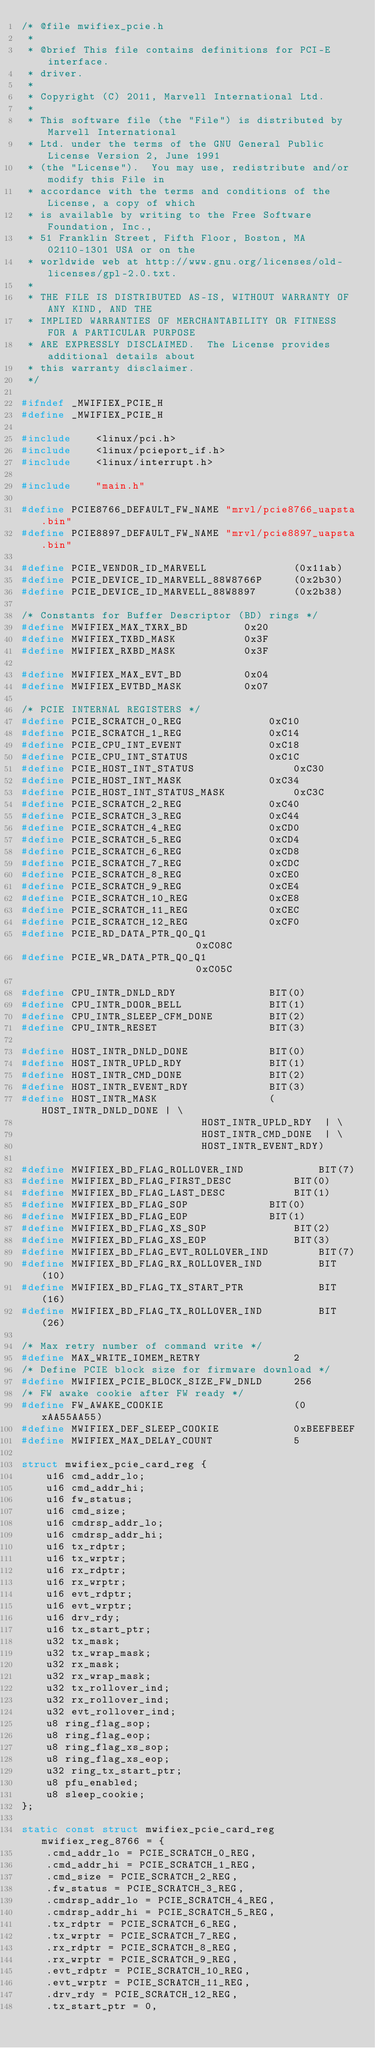Convert code to text. <code><loc_0><loc_0><loc_500><loc_500><_C_>/* @file mwifiex_pcie.h
 *
 * @brief This file contains definitions for PCI-E interface.
 * driver.
 *
 * Copyright (C) 2011, Marvell International Ltd.
 *
 * This software file (the "File") is distributed by Marvell International
 * Ltd. under the terms of the GNU General Public License Version 2, June 1991
 * (the "License").  You may use, redistribute and/or modify this File in
 * accordance with the terms and conditions of the License, a copy of which
 * is available by writing to the Free Software Foundation, Inc.,
 * 51 Franklin Street, Fifth Floor, Boston, MA 02110-1301 USA or on the
 * worldwide web at http://www.gnu.org/licenses/old-licenses/gpl-2.0.txt.
 *
 * THE FILE IS DISTRIBUTED AS-IS, WITHOUT WARRANTY OF ANY KIND, AND THE
 * IMPLIED WARRANTIES OF MERCHANTABILITY OR FITNESS FOR A PARTICULAR PURPOSE
 * ARE EXPRESSLY DISCLAIMED.  The License provides additional details about
 * this warranty disclaimer.
 */

#ifndef	_MWIFIEX_PCIE_H
#define	_MWIFIEX_PCIE_H

#include    <linux/pci.h>
#include    <linux/pcieport_if.h>
#include    <linux/interrupt.h>

#include    "main.h"

#define PCIE8766_DEFAULT_FW_NAME "mrvl/pcie8766_uapsta.bin"
#define PCIE8897_DEFAULT_FW_NAME "mrvl/pcie8897_uapsta.bin"

#define PCIE_VENDOR_ID_MARVELL              (0x11ab)
#define PCIE_DEVICE_ID_MARVELL_88W8766P		(0x2b30)
#define PCIE_DEVICE_ID_MARVELL_88W8897		(0x2b38)

/* Constants for Buffer Descriptor (BD) rings */
#define MWIFIEX_MAX_TXRX_BD			0x20
#define MWIFIEX_TXBD_MASK			0x3F
#define MWIFIEX_RXBD_MASK			0x3F

#define MWIFIEX_MAX_EVT_BD			0x04
#define MWIFIEX_EVTBD_MASK			0x07

/* PCIE INTERNAL REGISTERS */
#define PCIE_SCRATCH_0_REG				0xC10
#define PCIE_SCRATCH_1_REG				0xC14
#define PCIE_CPU_INT_EVENT				0xC18
#define PCIE_CPU_INT_STATUS				0xC1C
#define PCIE_HOST_INT_STATUS				0xC30
#define PCIE_HOST_INT_MASK				0xC34
#define PCIE_HOST_INT_STATUS_MASK			0xC3C
#define PCIE_SCRATCH_2_REG				0xC40
#define PCIE_SCRATCH_3_REG				0xC44
#define PCIE_SCRATCH_4_REG				0xCD0
#define PCIE_SCRATCH_5_REG				0xCD4
#define PCIE_SCRATCH_6_REG				0xCD8
#define PCIE_SCRATCH_7_REG				0xCDC
#define PCIE_SCRATCH_8_REG				0xCE0
#define PCIE_SCRATCH_9_REG				0xCE4
#define PCIE_SCRATCH_10_REG				0xCE8
#define PCIE_SCRATCH_11_REG				0xCEC
#define PCIE_SCRATCH_12_REG				0xCF0
#define PCIE_RD_DATA_PTR_Q0_Q1                          0xC08C
#define PCIE_WR_DATA_PTR_Q0_Q1                          0xC05C

#define CPU_INTR_DNLD_RDY				BIT(0)
#define CPU_INTR_DOOR_BELL				BIT(1)
#define CPU_INTR_SLEEP_CFM_DONE			BIT(2)
#define CPU_INTR_RESET					BIT(3)

#define HOST_INTR_DNLD_DONE				BIT(0)
#define HOST_INTR_UPLD_RDY				BIT(1)
#define HOST_INTR_CMD_DONE				BIT(2)
#define HOST_INTR_EVENT_RDY				BIT(3)
#define HOST_INTR_MASK					(HOST_INTR_DNLD_DONE | \
							 HOST_INTR_UPLD_RDY  | \
							 HOST_INTR_CMD_DONE  | \
							 HOST_INTR_EVENT_RDY)

#define MWIFIEX_BD_FLAG_ROLLOVER_IND			BIT(7)
#define MWIFIEX_BD_FLAG_FIRST_DESC			BIT(0)
#define MWIFIEX_BD_FLAG_LAST_DESC			BIT(1)
#define MWIFIEX_BD_FLAG_SOP				BIT(0)
#define MWIFIEX_BD_FLAG_EOP				BIT(1)
#define MWIFIEX_BD_FLAG_XS_SOP				BIT(2)
#define MWIFIEX_BD_FLAG_XS_EOP				BIT(3)
#define MWIFIEX_BD_FLAG_EVT_ROLLOVER_IND		BIT(7)
#define MWIFIEX_BD_FLAG_RX_ROLLOVER_IND			BIT(10)
#define MWIFIEX_BD_FLAG_TX_START_PTR			BIT(16)
#define MWIFIEX_BD_FLAG_TX_ROLLOVER_IND			BIT(26)

/* Max retry number of command write */
#define MAX_WRITE_IOMEM_RETRY				2
/* Define PCIE block size for firmware download */
#define MWIFIEX_PCIE_BLOCK_SIZE_FW_DNLD		256
/* FW awake cookie after FW ready */
#define FW_AWAKE_COOKIE						(0xAA55AA55)
#define MWIFIEX_DEF_SLEEP_COOKIE			0xBEEFBEEF
#define MWIFIEX_MAX_DELAY_COUNT				5

struct mwifiex_pcie_card_reg {
	u16 cmd_addr_lo;
	u16 cmd_addr_hi;
	u16 fw_status;
	u16 cmd_size;
	u16 cmdrsp_addr_lo;
	u16 cmdrsp_addr_hi;
	u16 tx_rdptr;
	u16 tx_wrptr;
	u16 rx_rdptr;
	u16 rx_wrptr;
	u16 evt_rdptr;
	u16 evt_wrptr;
	u16 drv_rdy;
	u16 tx_start_ptr;
	u32 tx_mask;
	u32 tx_wrap_mask;
	u32 rx_mask;
	u32 rx_wrap_mask;
	u32 tx_rollover_ind;
	u32 rx_rollover_ind;
	u32 evt_rollover_ind;
	u8 ring_flag_sop;
	u8 ring_flag_eop;
	u8 ring_flag_xs_sop;
	u8 ring_flag_xs_eop;
	u32 ring_tx_start_ptr;
	u8 pfu_enabled;
	u8 sleep_cookie;
};

static const struct mwifiex_pcie_card_reg mwifiex_reg_8766 = {
	.cmd_addr_lo = PCIE_SCRATCH_0_REG,
	.cmd_addr_hi = PCIE_SCRATCH_1_REG,
	.cmd_size = PCIE_SCRATCH_2_REG,
	.fw_status = PCIE_SCRATCH_3_REG,
	.cmdrsp_addr_lo = PCIE_SCRATCH_4_REG,
	.cmdrsp_addr_hi = PCIE_SCRATCH_5_REG,
	.tx_rdptr = PCIE_SCRATCH_6_REG,
	.tx_wrptr = PCIE_SCRATCH_7_REG,
	.rx_rdptr = PCIE_SCRATCH_8_REG,
	.rx_wrptr = PCIE_SCRATCH_9_REG,
	.evt_rdptr = PCIE_SCRATCH_10_REG,
	.evt_wrptr = PCIE_SCRATCH_11_REG,
	.drv_rdy = PCIE_SCRATCH_12_REG,
	.tx_start_ptr = 0,</code> 